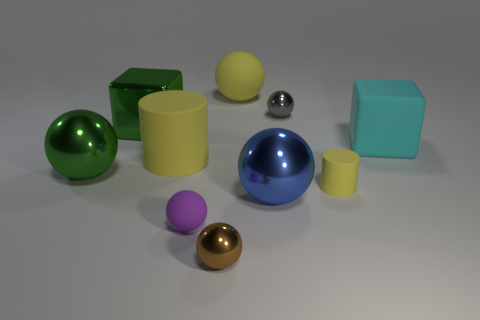Subtract all yellow cylinders. How many were subtracted if there are1yellow cylinders left? 1 Subtract 1 cylinders. How many cylinders are left? 1 Subtract all green cubes. How many cubes are left? 1 Subtract all small brown balls. How many balls are left? 5 Subtract all balls. How many objects are left? 4 Subtract all purple cubes. Subtract all gray cylinders. How many cubes are left? 2 Subtract all green cylinders. How many purple cubes are left? 0 Subtract all tiny rubber objects. Subtract all small brown rubber cubes. How many objects are left? 8 Add 3 matte objects. How many matte objects are left? 8 Add 8 big matte cylinders. How many big matte cylinders exist? 9 